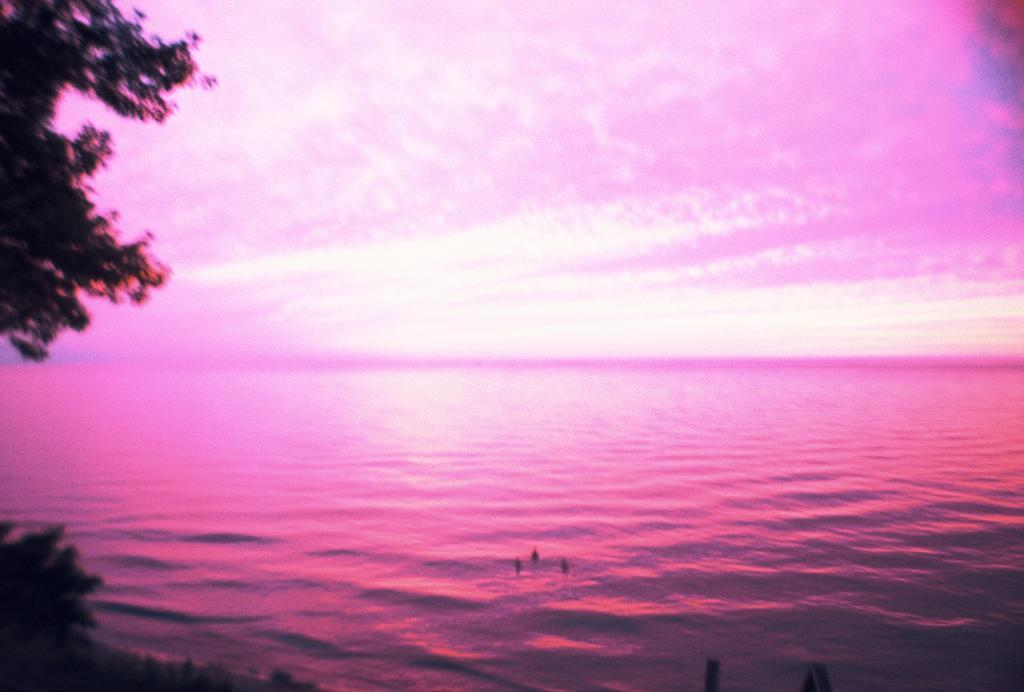What is the main feature in the middle of the image? There is an ocean in the middle of the image. What type of vegetation can be seen on the left side of the image? There are trees on the left side of the image. How would you describe the overall color tone of the image? The image appears to have a pink color tone. What type of dress is the passenger wearing in the image? There is no passenger present in the image, so it is not possible to determine what type of dress they might be wearing. 